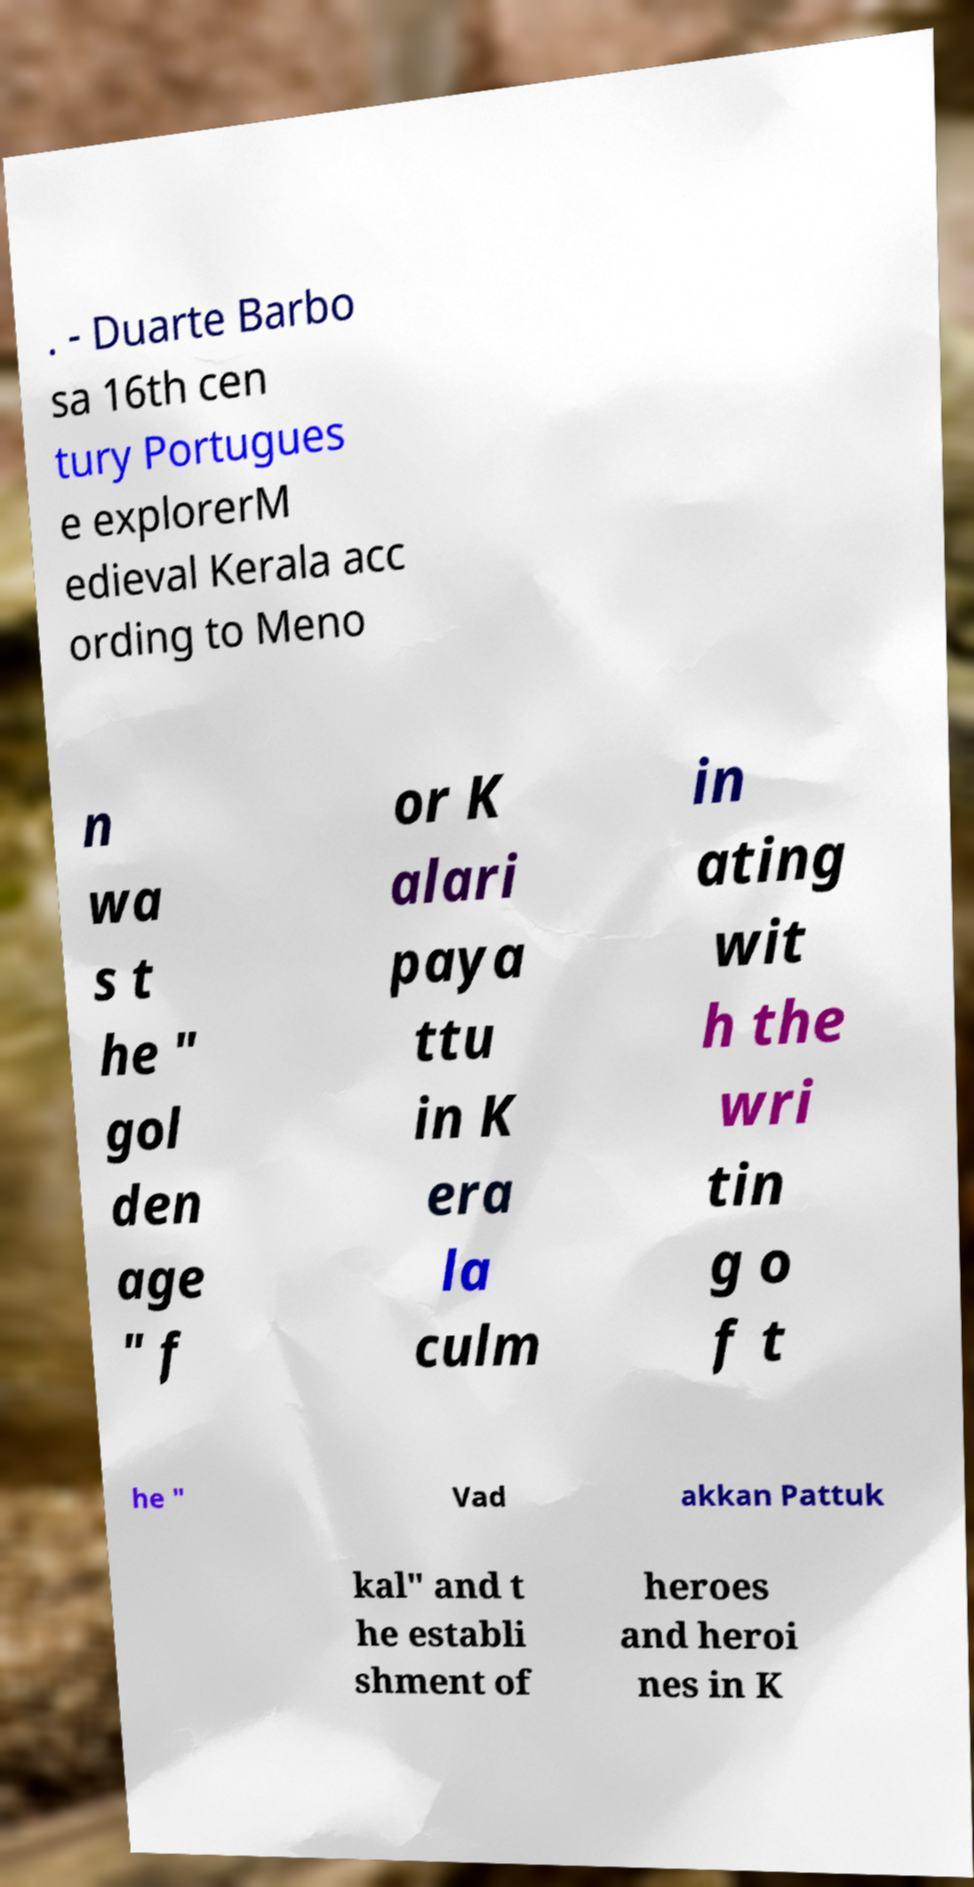I need the written content from this picture converted into text. Can you do that? . - Duarte Barbo sa 16th cen tury Portugues e explorerM edieval Kerala acc ording to Meno n wa s t he " gol den age " f or K alari paya ttu in K era la culm in ating wit h the wri tin g o f t he " Vad akkan Pattuk kal" and t he establi shment of heroes and heroi nes in K 